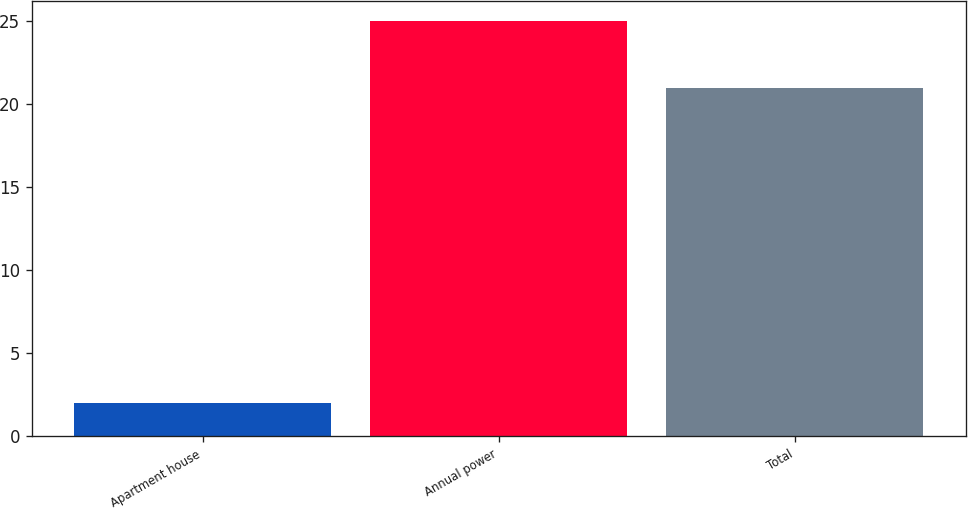Convert chart to OTSL. <chart><loc_0><loc_0><loc_500><loc_500><bar_chart><fcel>Apartment house<fcel>Annual power<fcel>Total<nl><fcel>2<fcel>25<fcel>21<nl></chart> 